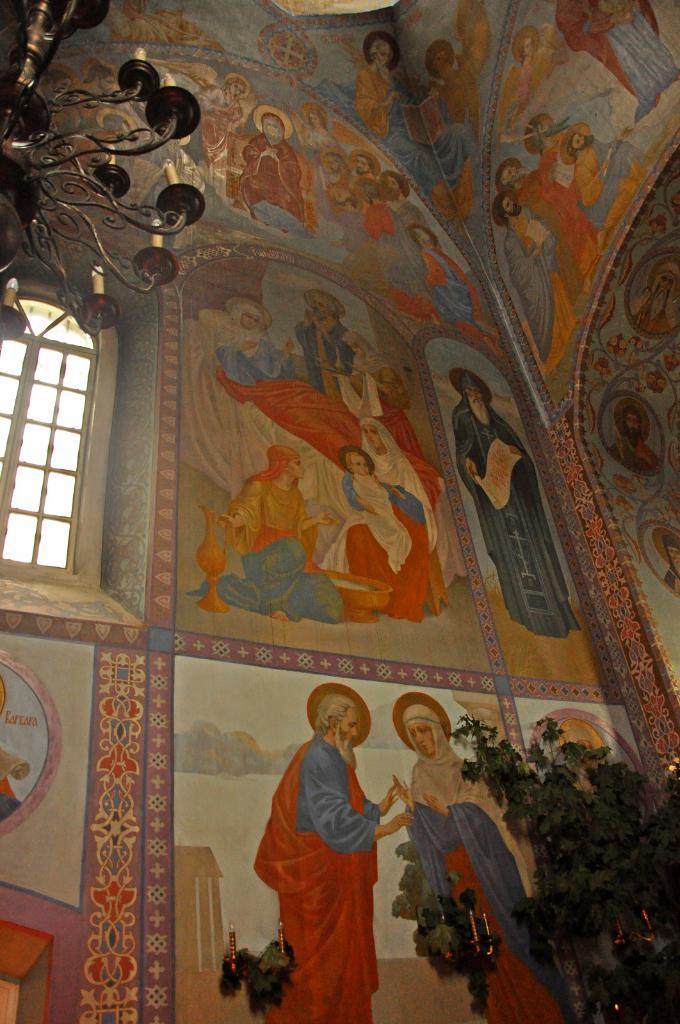Describe this image in one or two sentences. In this image there is a wall, on the wall there is some painting, at the bottom there are some plants and candles. At the top there is one chandelier, on the left side there is one window. 